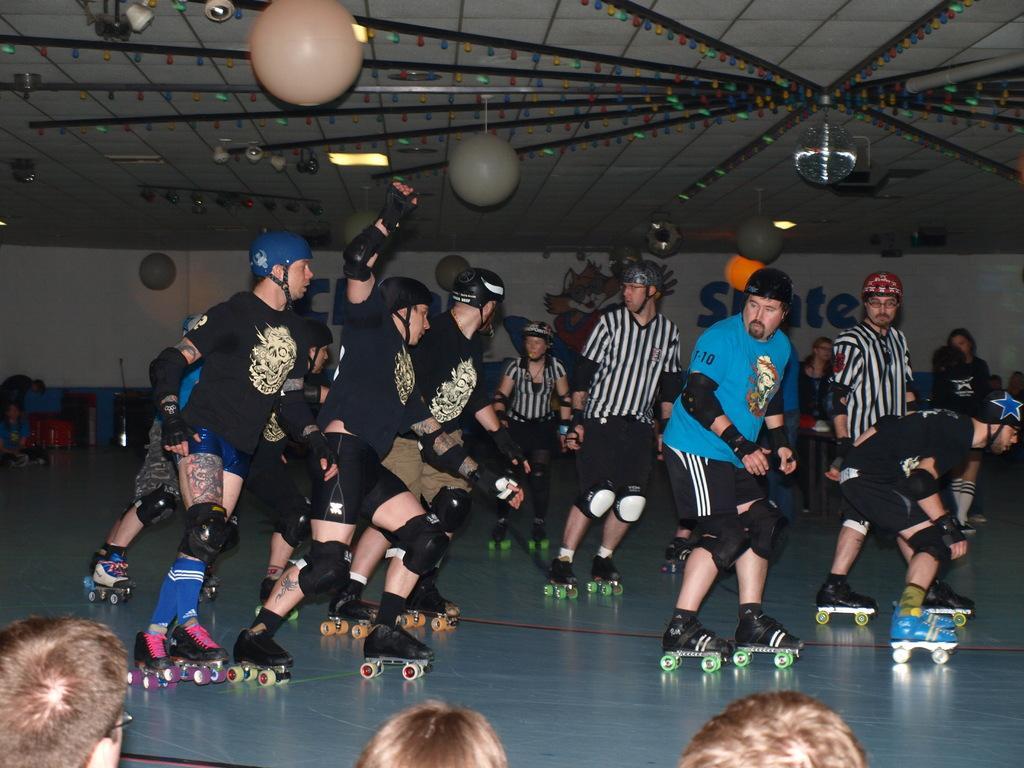Can you describe this image briefly? In this image we can see few people with skate shoes on the floor, there are few lights to the ceiling and a wall with text and image in the background. 